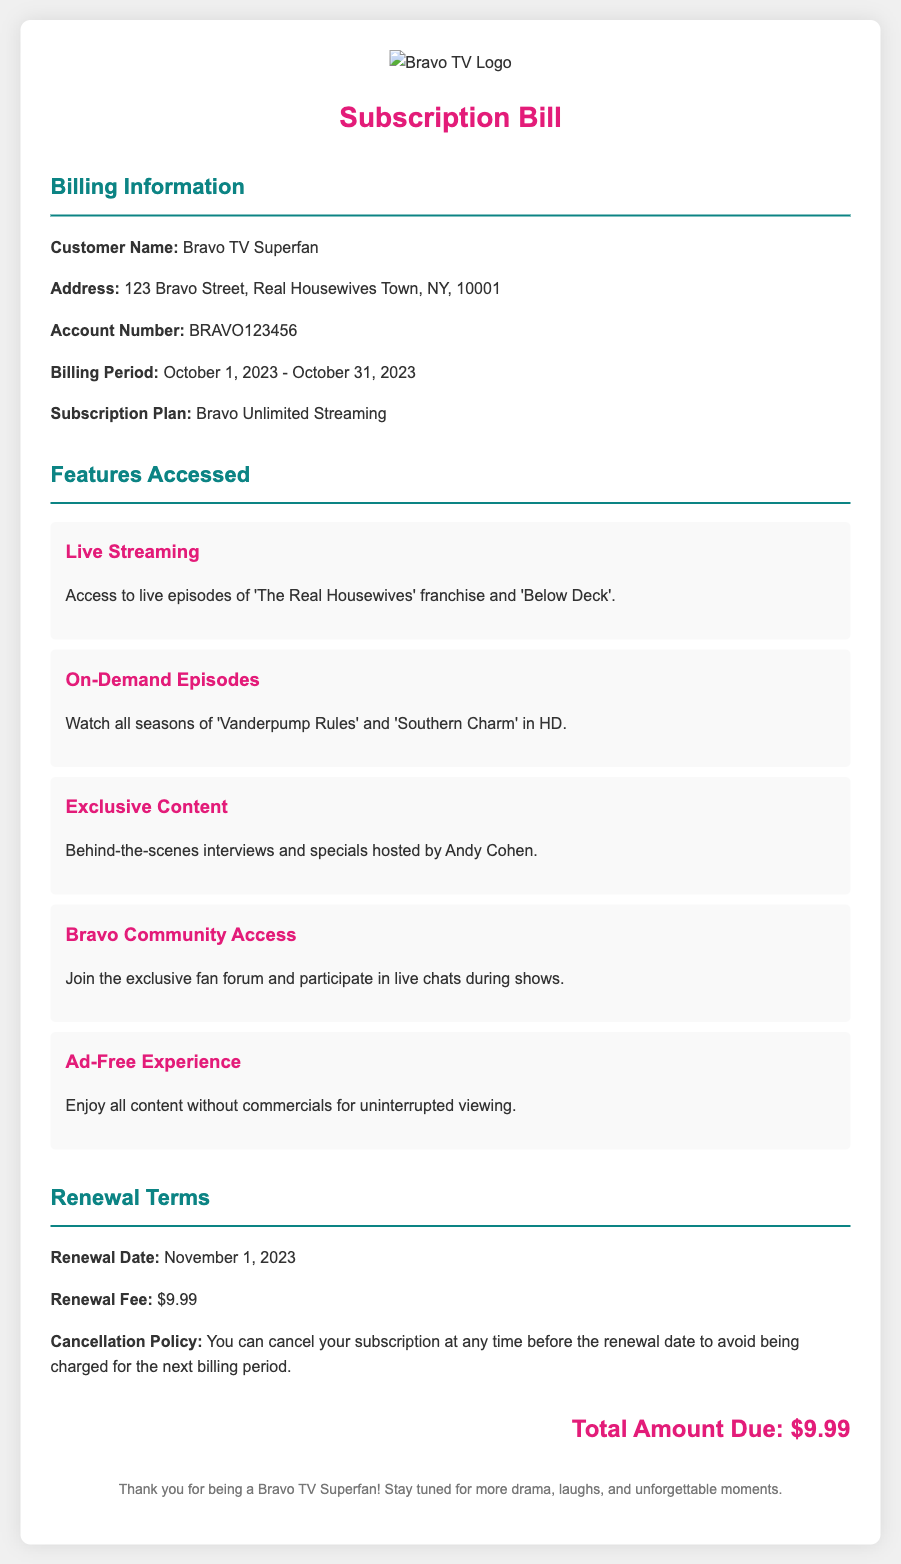What is the customer name? The document states the customer name as "Bravo TV Superfan."
Answer: Bravo TV Superfan What is the billing period? The billing period is mentioned as "October 1, 2023 - October 31, 2023."
Answer: October 1, 2023 - October 31, 2023 What is the renewal fee? The renewal fee listed in the document is "$9.99."
Answer: $9.99 What feature allows watching episodes in HD? The feature that allows watching episodes in HD is "On-Demand Episodes."
Answer: On-Demand Episodes How many features are accessed in total? The document lists five features accessed, which include live streaming, on-demand episodes, exclusive content, community access, and ad-free experience.
Answer: Five What is the cancellation policy? The cancellation policy states you can cancel at any time before the renewal date to avoid the next charge.
Answer: You can cancel at any time before the renewal date What is the total amount due? The total amount due is highlighted as "$9.99" in the document.
Answer: $9.99 What is the renewal date? The renewal date provided is "November 1, 2023."
Answer: November 1, 2023 What exclusive content feature is mentioned? The exclusive content feature includes "Behind-the-scenes interviews and specials hosted by Andy Cohen."
Answer: Behind-the-scenes interviews and specials hosted by Andy Cohen 